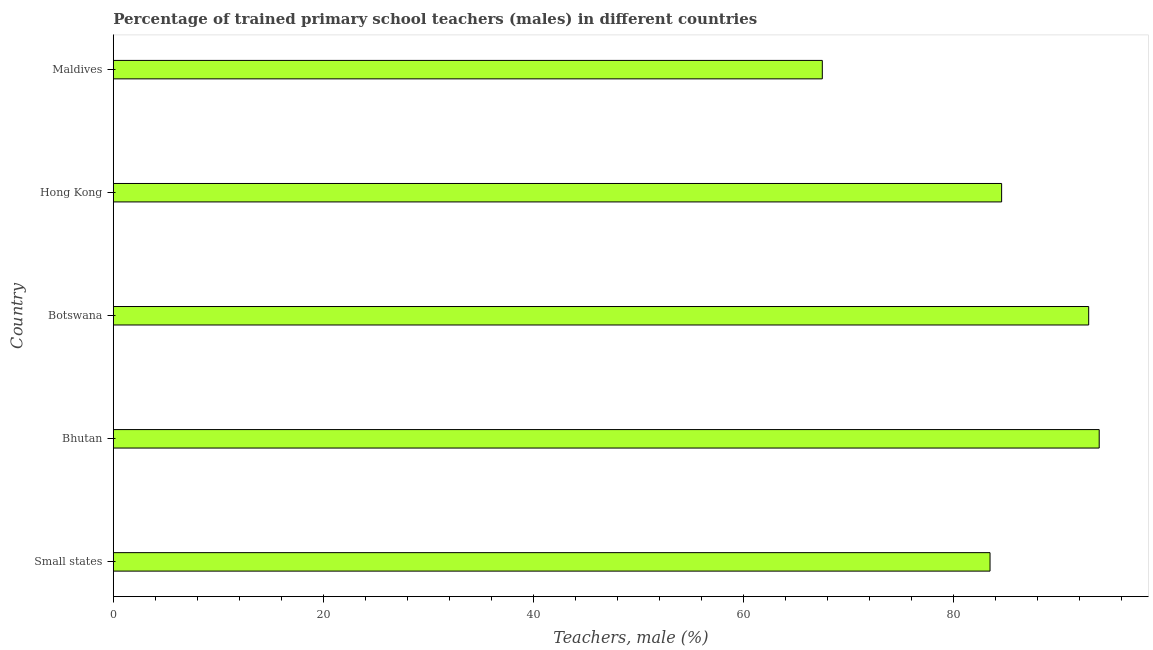Does the graph contain any zero values?
Give a very brief answer. No. Does the graph contain grids?
Your answer should be very brief. No. What is the title of the graph?
Make the answer very short. Percentage of trained primary school teachers (males) in different countries. What is the label or title of the X-axis?
Offer a terse response. Teachers, male (%). What is the percentage of trained male teachers in Hong Kong?
Make the answer very short. 84.6. Across all countries, what is the maximum percentage of trained male teachers?
Your answer should be compact. 93.89. Across all countries, what is the minimum percentage of trained male teachers?
Make the answer very short. 67.52. In which country was the percentage of trained male teachers maximum?
Provide a succinct answer. Bhutan. In which country was the percentage of trained male teachers minimum?
Your answer should be very brief. Maldives. What is the sum of the percentage of trained male teachers?
Offer a terse response. 422.41. What is the difference between the percentage of trained male teachers in Botswana and Maldives?
Your answer should be very brief. 25.37. What is the average percentage of trained male teachers per country?
Give a very brief answer. 84.48. What is the median percentage of trained male teachers?
Keep it short and to the point. 84.6. In how many countries, is the percentage of trained male teachers greater than 48 %?
Offer a terse response. 5. What is the ratio of the percentage of trained male teachers in Bhutan to that in Maldives?
Your response must be concise. 1.39. What is the difference between the highest and the lowest percentage of trained male teachers?
Provide a succinct answer. 26.37. In how many countries, is the percentage of trained male teachers greater than the average percentage of trained male teachers taken over all countries?
Provide a short and direct response. 3. How many bars are there?
Provide a short and direct response. 5. Are all the bars in the graph horizontal?
Offer a terse response. Yes. How many countries are there in the graph?
Your answer should be very brief. 5. Are the values on the major ticks of X-axis written in scientific E-notation?
Offer a very short reply. No. What is the Teachers, male (%) in Small states?
Give a very brief answer. 83.5. What is the Teachers, male (%) in Bhutan?
Ensure brevity in your answer.  93.89. What is the Teachers, male (%) of Botswana?
Provide a succinct answer. 92.89. What is the Teachers, male (%) in Hong Kong?
Keep it short and to the point. 84.6. What is the Teachers, male (%) in Maldives?
Your response must be concise. 67.52. What is the difference between the Teachers, male (%) in Small states and Bhutan?
Your response must be concise. -10.4. What is the difference between the Teachers, male (%) in Small states and Botswana?
Keep it short and to the point. -9.4. What is the difference between the Teachers, male (%) in Small states and Hong Kong?
Your answer should be very brief. -1.1. What is the difference between the Teachers, male (%) in Small states and Maldives?
Provide a succinct answer. 15.97. What is the difference between the Teachers, male (%) in Bhutan and Botswana?
Keep it short and to the point. 1. What is the difference between the Teachers, male (%) in Bhutan and Hong Kong?
Make the answer very short. 9.29. What is the difference between the Teachers, male (%) in Bhutan and Maldives?
Make the answer very short. 26.37. What is the difference between the Teachers, male (%) in Botswana and Hong Kong?
Keep it short and to the point. 8.29. What is the difference between the Teachers, male (%) in Botswana and Maldives?
Offer a terse response. 25.37. What is the difference between the Teachers, male (%) in Hong Kong and Maldives?
Offer a terse response. 17.08. What is the ratio of the Teachers, male (%) in Small states to that in Bhutan?
Your response must be concise. 0.89. What is the ratio of the Teachers, male (%) in Small states to that in Botswana?
Ensure brevity in your answer.  0.9. What is the ratio of the Teachers, male (%) in Small states to that in Hong Kong?
Ensure brevity in your answer.  0.99. What is the ratio of the Teachers, male (%) in Small states to that in Maldives?
Make the answer very short. 1.24. What is the ratio of the Teachers, male (%) in Bhutan to that in Botswana?
Offer a very short reply. 1.01. What is the ratio of the Teachers, male (%) in Bhutan to that in Hong Kong?
Provide a succinct answer. 1.11. What is the ratio of the Teachers, male (%) in Bhutan to that in Maldives?
Your answer should be compact. 1.39. What is the ratio of the Teachers, male (%) in Botswana to that in Hong Kong?
Your response must be concise. 1.1. What is the ratio of the Teachers, male (%) in Botswana to that in Maldives?
Provide a succinct answer. 1.38. What is the ratio of the Teachers, male (%) in Hong Kong to that in Maldives?
Offer a terse response. 1.25. 